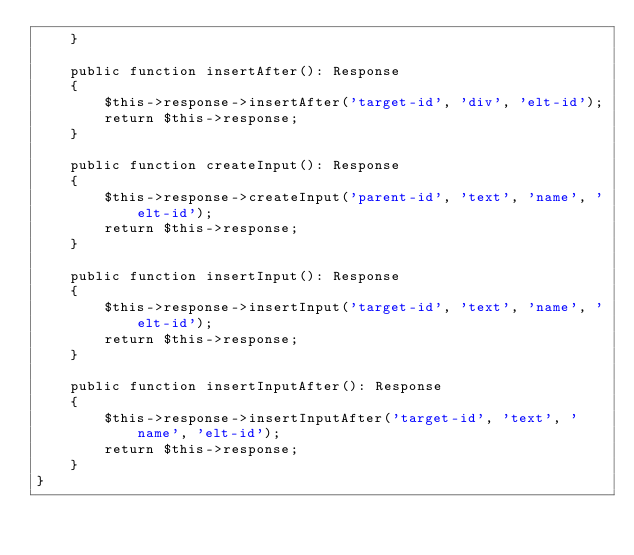Convert code to text. <code><loc_0><loc_0><loc_500><loc_500><_PHP_>    }

    public function insertAfter(): Response
    {
        $this->response->insertAfter('target-id', 'div', 'elt-id');
        return $this->response;
    }

    public function createInput(): Response
    {
        $this->response->createInput('parent-id', 'text', 'name', 'elt-id');
        return $this->response;
    }

    public function insertInput(): Response
    {
        $this->response->insertInput('target-id', 'text', 'name', 'elt-id');
        return $this->response;
    }

    public function insertInputAfter(): Response
    {
        $this->response->insertInputAfter('target-id', 'text', 'name', 'elt-id');
        return $this->response;
    }
}
</code> 